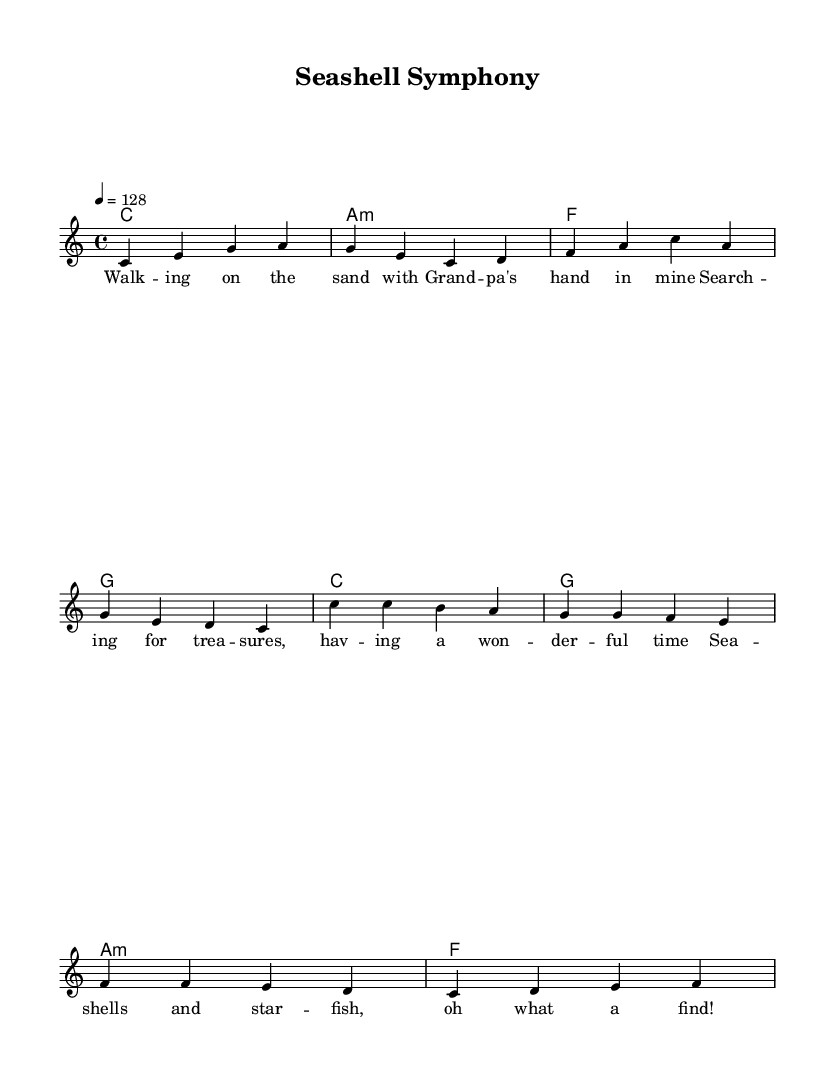What is the key signature of this music? The key signature indicated in the global section is C major, meaning there are no sharps or flats present.
Answer: C major What is the time signature of this piece? The time signature is found in the global section and is set to 4/4, which is common time allowing for four beats per measure.
Answer: 4/4 What is the tempo marking for this composition? The tempo marking is also found in the global section, showing a tempo of 128 beats per minute.
Answer: 128 How many measures are in the verse section? The verse section has four measures, which can be counted from the melody part where the notes are grouped.
Answer: 4 What is the last chord in the chorus? The last chord of the chorus is specified in the harmonies section of the score and is marked as F.
Answer: F What type of song is this based on its lyrics? The lyrics depict themes of exploring the beach and finding treasures, indicating it is an upbeat pop song about beach adventures.
Answer: Upbeat pop How does the melody start in the verse? The melody begins with the note C in the verse section, as shown in the first measure of the melody.
Answer: C 